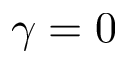<formula> <loc_0><loc_0><loc_500><loc_500>\gamma = 0</formula> 